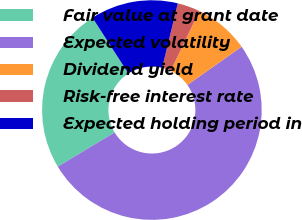Convert chart. <chart><loc_0><loc_0><loc_500><loc_500><pie_chart><fcel>Fair value at grant date<fcel>Expected volatility<fcel>Dividend yield<fcel>Risk-free interest rate<fcel>Expected holding period in<nl><fcel>24.52%<fcel>51.17%<fcel>8.1%<fcel>3.32%<fcel>12.89%<nl></chart> 